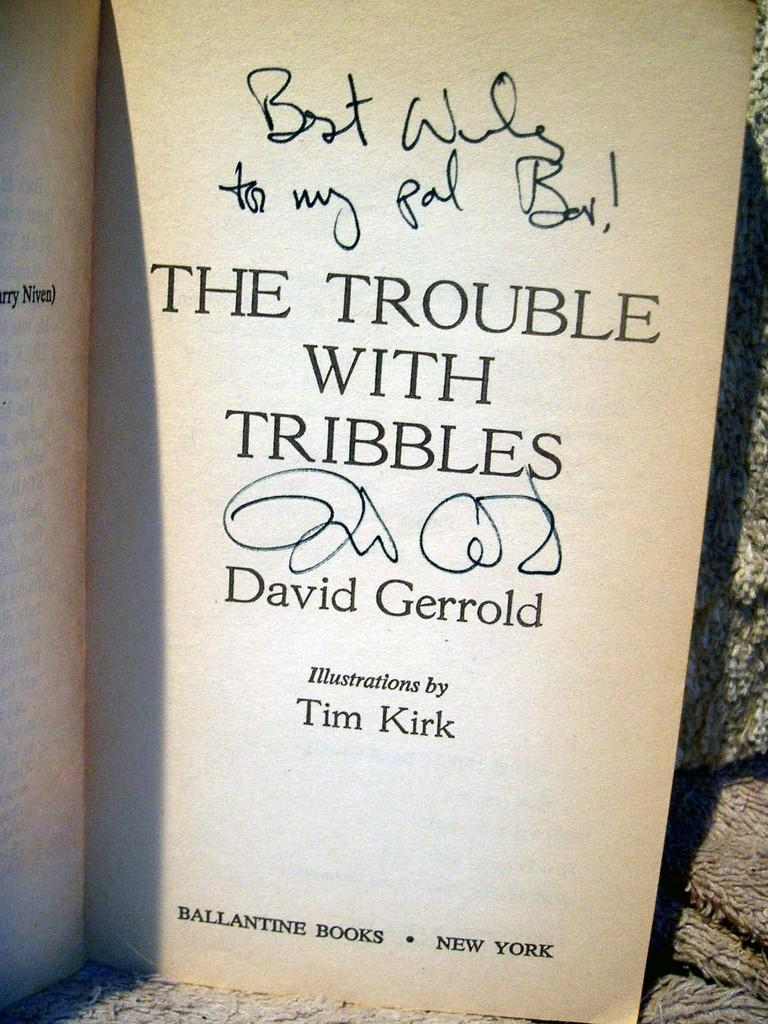<image>
Create a compact narrative representing the image presented. a book called the trouble with tribbles by david gerrold 